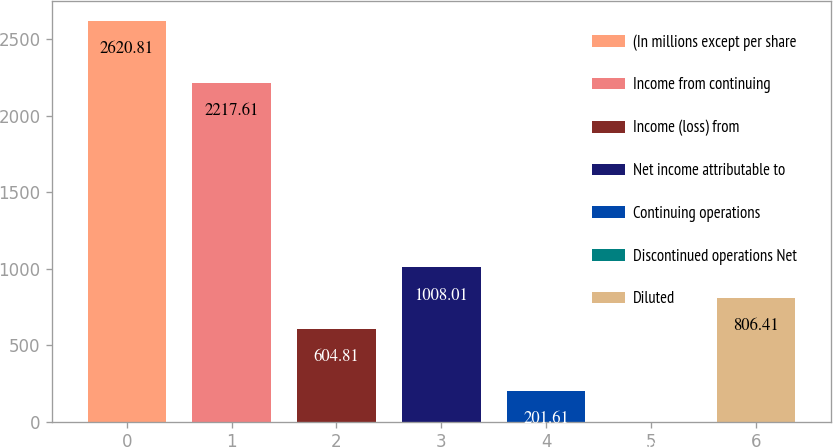Convert chart to OTSL. <chart><loc_0><loc_0><loc_500><loc_500><bar_chart><fcel>(In millions except per share<fcel>Income from continuing<fcel>Income (loss) from<fcel>Net income attributable to<fcel>Continuing operations<fcel>Discontinued operations Net<fcel>Diluted<nl><fcel>2620.81<fcel>2217.61<fcel>604.81<fcel>1008.01<fcel>201.61<fcel>0.01<fcel>806.41<nl></chart> 